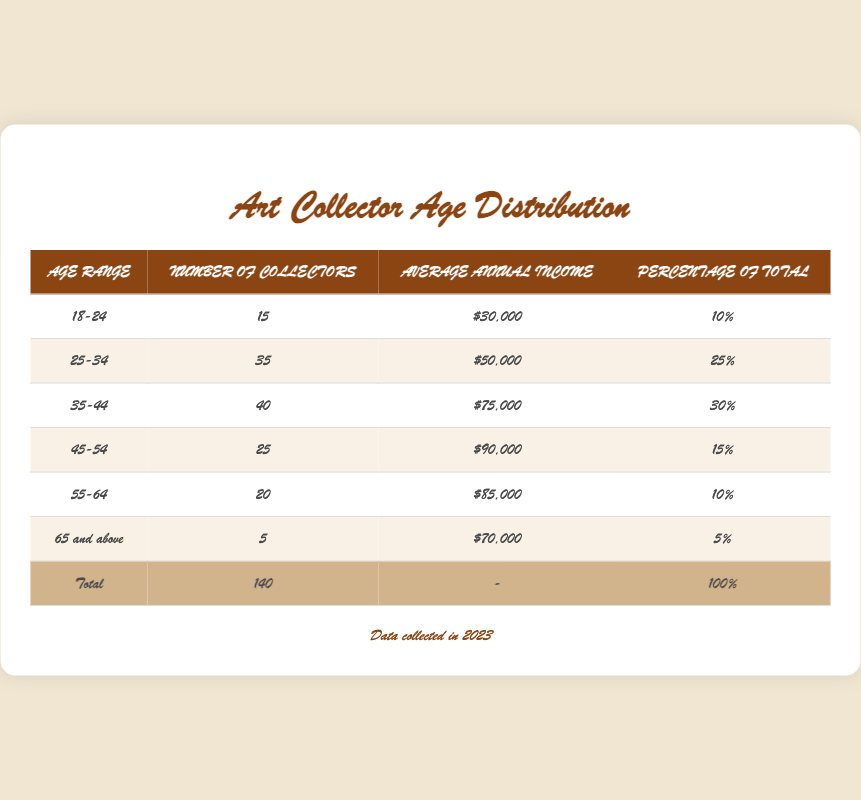What is the age range with the highest number of collectors? By looking at the table, I can see that the age range "35-44" has the highest number of collectors, with a total of 40.
Answer: 35-44 What percentage of the total collectors are aged 25-34? The table shows that the percentage of total collectors for the age range "25-34" is 25%.
Answer: 25% Is the average annual income for collectors aged 55-64 higher than those aged 45-54? The average annual income for collectors aged 55-64 is $85,000, while for those aged 45-54 it is $90,000. Since $85,000 is less than $90,000, the statement is false.
Answer: No What is the total number of collectors aged 18-24 and 55-64 combined? To find this, I can add the number of collectors in both age ranges: 15 (for 18-24) + 20 (for 55-64) = 35.
Answer: 35 True or False: The percentage of collectors aged 65 and above is more than 10%. The table indicates that the percentage of collectors aged 65 and above is only 5%, which is less than 10%. Thus, the statement is false.
Answer: False What is the average annual income of collectors in the age range 25-34? The table indicates that the average annual income for collectors aged 25-34 is $50,000.
Answer: $50,000 What is the combined average annual income of the age ranges 35-44 and 45-54? To find this combined average, I first sum the average incomes: $75,000 (for 35-44) + $90,000 (for 45-54) = $165,000. Then I divide by 2 to find the average, giving me $165,000 / 2 = $82,500.
Answer: $82,500 Which age range has the lowest number of collectors? According to the table, the "65 and above" age range has the lowest number of collectors, with only 5.
Answer: 65 and above True or False: There are more collectors aged 45-54 than aged 18-24. The table shows that there are 25 collectors aged 45-54 and 15 collectors aged 18-24. Since 25 is greater than 15, the statement is true.
Answer: True 